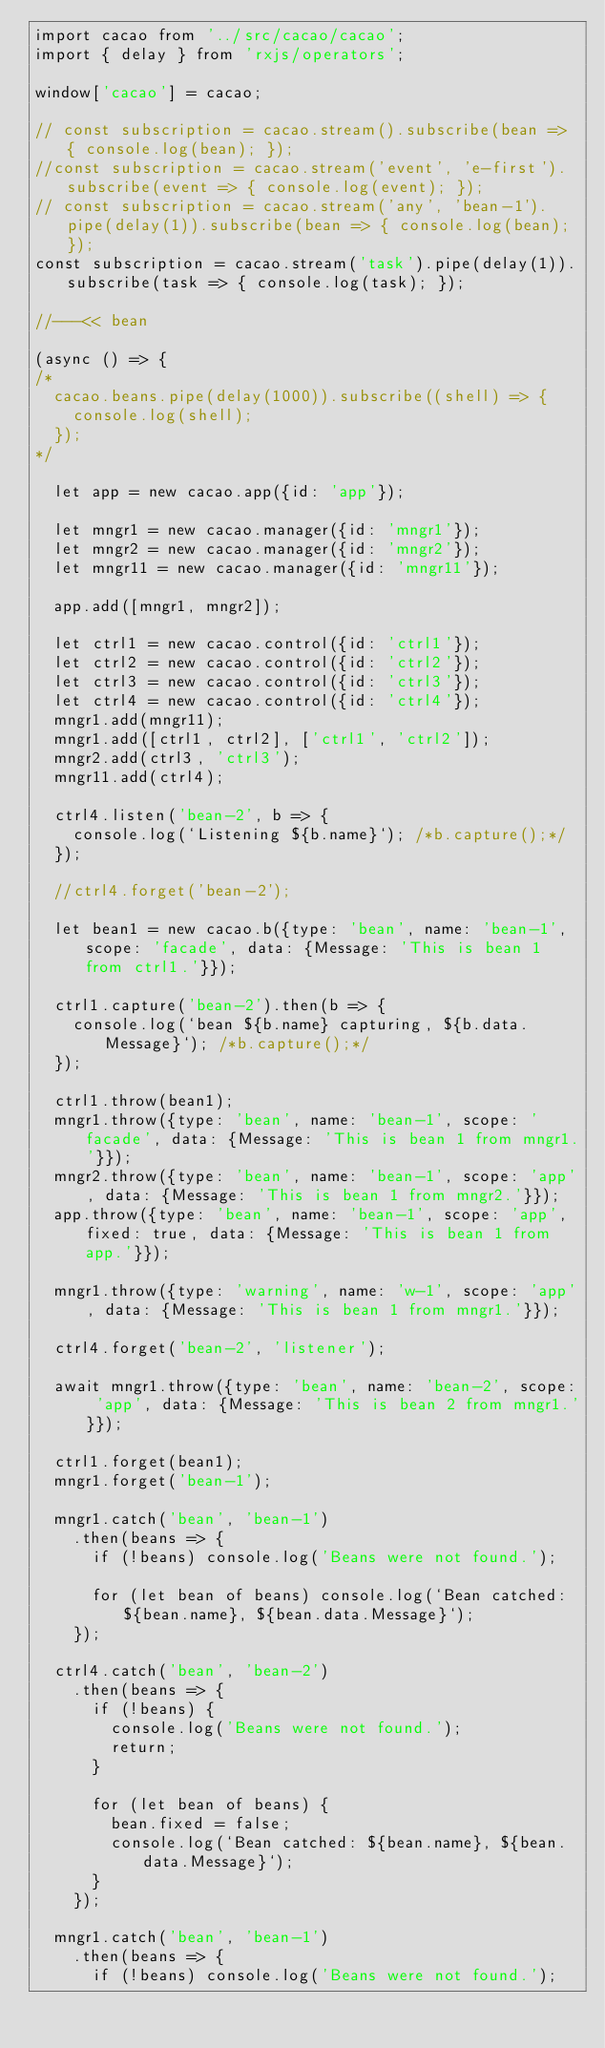<code> <loc_0><loc_0><loc_500><loc_500><_JavaScript_>import cacao from '../src/cacao/cacao';
import { delay } from 'rxjs/operators';

window['cacao'] = cacao;

// const subscription = cacao.stream().subscribe(bean => { console.log(bean); });
//const subscription = cacao.stream('event', 'e-first').subscribe(event => { console.log(event); });
// const subscription = cacao.stream('any', 'bean-1').pipe(delay(1)).subscribe(bean => { console.log(bean); });
const subscription = cacao.stream('task').pipe(delay(1)).subscribe(task => { console.log(task); });

//---<< bean

(async () => {
/*
	cacao.beans.pipe(delay(1000)).subscribe((shell) => {
		console.log(shell);
	});
*/

	let app = new cacao.app({id: 'app'});

	let mngr1 = new cacao.manager({id: 'mngr1'});
	let mngr2 = new cacao.manager({id: 'mngr2'});
	let mngr11 = new cacao.manager({id: 'mngr11'});

	app.add([mngr1, mngr2]);

	let ctrl1 = new cacao.control({id: 'ctrl1'});
	let ctrl2 = new cacao.control({id: 'ctrl2'});
	let ctrl3 = new cacao.control({id: 'ctrl3'});
	let ctrl4 = new cacao.control({id: 'ctrl4'});
	mngr1.add(mngr11);
	mngr1.add([ctrl1, ctrl2], ['ctrl1', 'ctrl2']);
	mngr2.add(ctrl3, 'ctrl3');
	mngr11.add(ctrl4);

	ctrl4.listen('bean-2', b => {
		console.log(`Listening ${b.name}`); /*b.capture();*/
	});

	//ctrl4.forget('bean-2');

	let bean1 = new cacao.b({type: 'bean', name: 'bean-1', scope: 'facade', data: {Message: 'This is bean 1 from ctrl1.'}});

	ctrl1.capture('bean-2').then(b => {
		console.log(`bean ${b.name} capturing, ${b.data.Message}`); /*b.capture();*/
	});

	ctrl1.throw(bean1);
	mngr1.throw({type: 'bean', name: 'bean-1', scope: 'facade', data: {Message: 'This is bean 1 from mngr1.'}});
	mngr2.throw({type: 'bean', name: 'bean-1', scope: 'app', data: {Message: 'This is bean 1 from mngr2.'}});
	app.throw({type: 'bean', name: 'bean-1', scope: 'app', fixed: true, data: {Message: 'This is bean 1 from app.'}});

	mngr1.throw({type: 'warning', name: 'w-1', scope: 'app', data: {Message: 'This is bean 1 from mngr1.'}});

	ctrl4.forget('bean-2', 'listener');

	await mngr1.throw({type: 'bean', name: 'bean-2', scope: 'app', data: {Message: 'This is bean 2 from mngr1.'}});

	ctrl1.forget(bean1);
	mngr1.forget('bean-1');

	mngr1.catch('bean', 'bean-1')
		.then(beans => {
			if (!beans) console.log('Beans were not found.');

			for (let bean of beans) console.log(`Bean catched: ${bean.name}, ${bean.data.Message}`);
		});

	ctrl4.catch('bean', 'bean-2')
		.then(beans => {
			if (!beans) {
				console.log('Beans were not found.');
				return;
			}

			for (let bean of beans) {
				bean.fixed = false;
				console.log(`Bean catched: ${bean.name}, ${bean.data.Message}`);
			}
		});

	mngr1.catch('bean', 'bean-1')
		.then(beans => {
			if (!beans) console.log('Beans were not found.');
</code> 